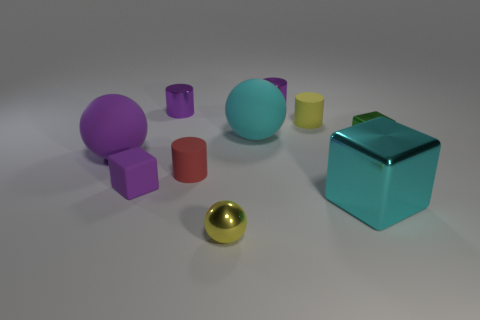There is a small cylinder that is the same color as the small metal ball; what is it made of?
Provide a succinct answer. Rubber. There is a large matte object that is behind the green object; what shape is it?
Offer a terse response. Sphere. How many objects are either tiny green shiny blocks or small red matte balls?
Your answer should be very brief. 1. Does the cyan block have the same size as the rubber cylinder that is to the left of the small yellow cylinder?
Provide a succinct answer. No. What number of other objects are the same material as the large cyan ball?
Provide a short and direct response. 4. How many things are either big things behind the red thing or tiny red matte cylinders that are on the left side of the small green block?
Provide a succinct answer. 3. There is a tiny object that is the same shape as the big purple matte thing; what material is it?
Offer a terse response. Metal. Are there any brown metal cylinders?
Give a very brief answer. No. What size is the purple object that is both left of the red cylinder and behind the yellow rubber object?
Ensure brevity in your answer.  Small. The small yellow metal object is what shape?
Provide a succinct answer. Sphere. 